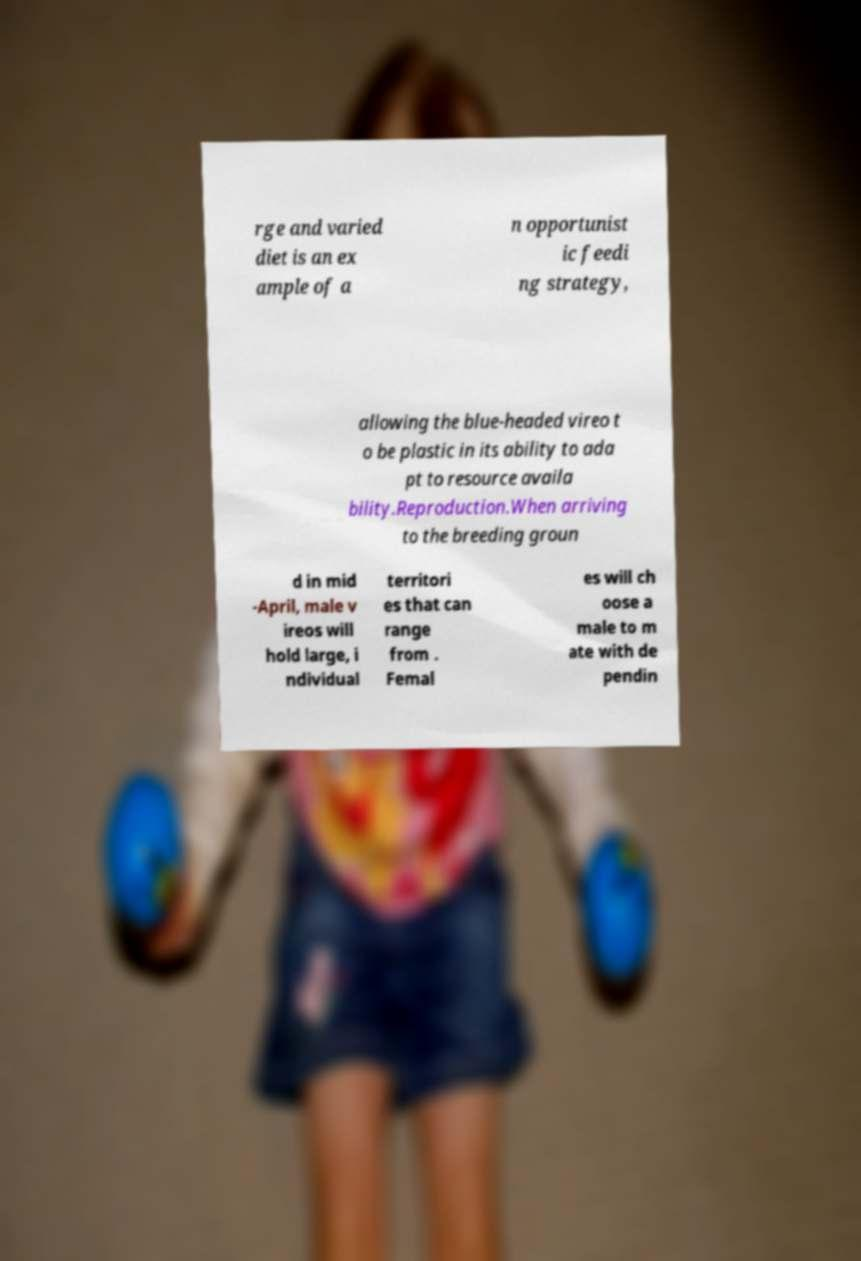What messages or text are displayed in this image? I need them in a readable, typed format. rge and varied diet is an ex ample of a n opportunist ic feedi ng strategy, allowing the blue-headed vireo t o be plastic in its ability to ada pt to resource availa bility.Reproduction.When arriving to the breeding groun d in mid -April, male v ireos will hold large, i ndividual territori es that can range from . Femal es will ch oose a male to m ate with de pendin 